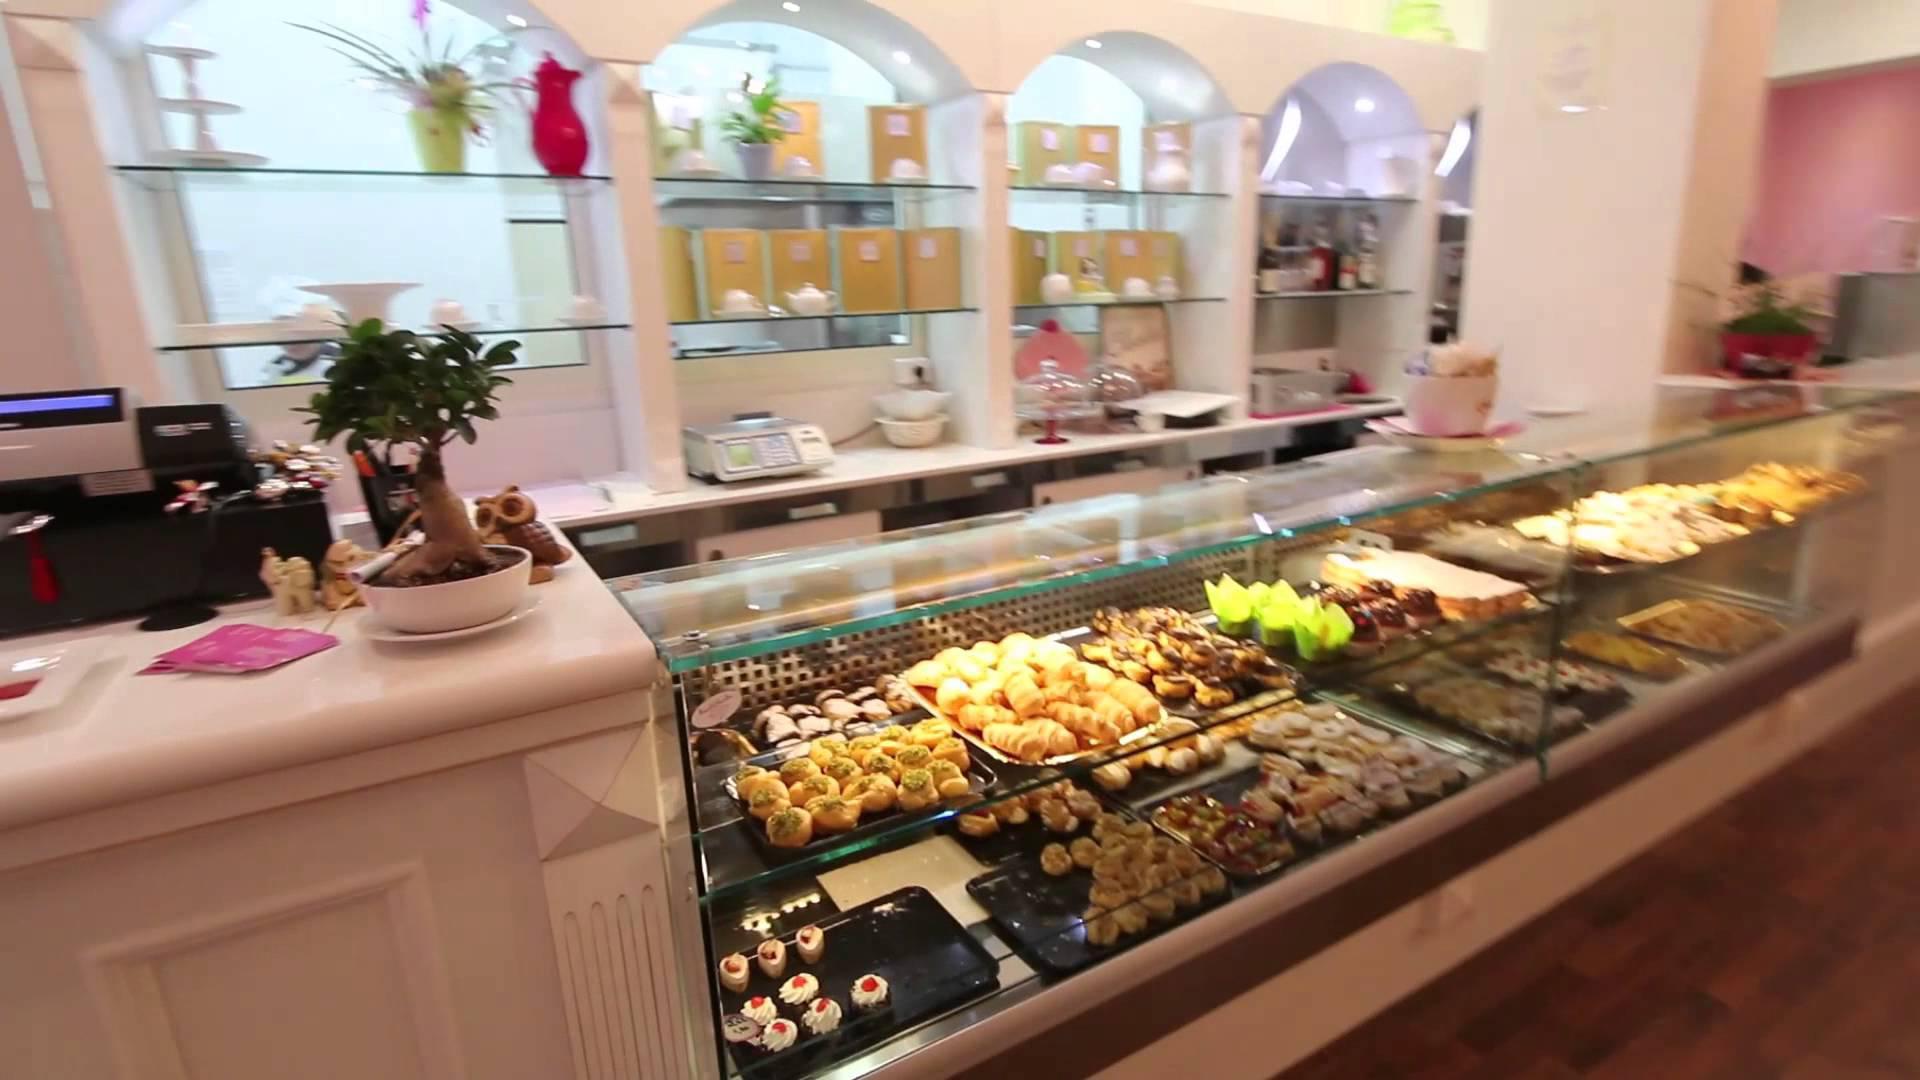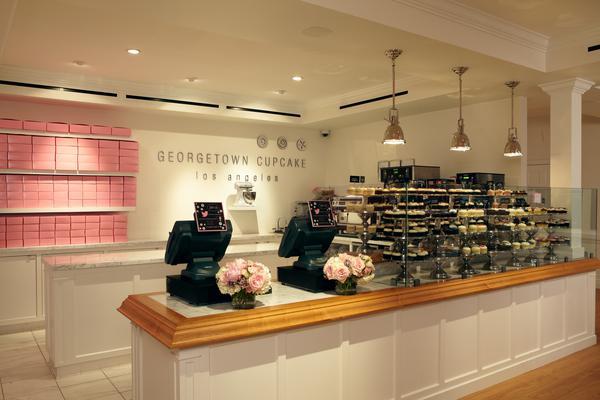The first image is the image on the left, the second image is the image on the right. Given the left and right images, does the statement "A bakery in one image has an indoor seating area for customers." hold true? Answer yes or no. No. 